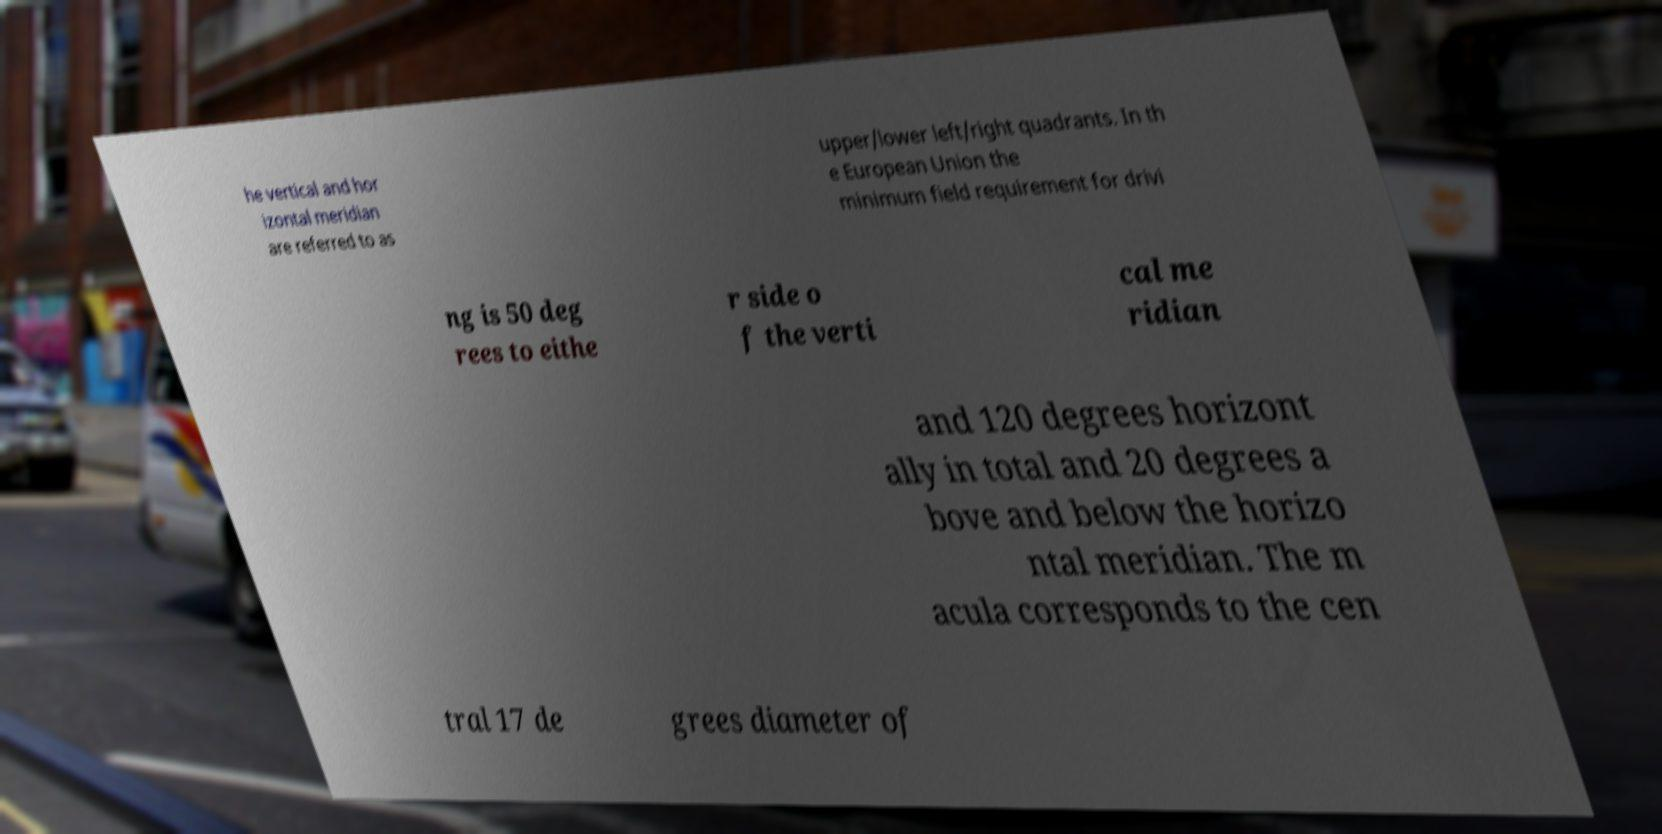Can you read and provide the text displayed in the image?This photo seems to have some interesting text. Can you extract and type it out for me? he vertical and hor izontal meridian are referred to as upper/lower left/right quadrants. In th e European Union the minimum field requirement for drivi ng is 50 deg rees to eithe r side o f the verti cal me ridian and 120 degrees horizont ally in total and 20 degrees a bove and below the horizo ntal meridian. The m acula corresponds to the cen tral 17 de grees diameter of 